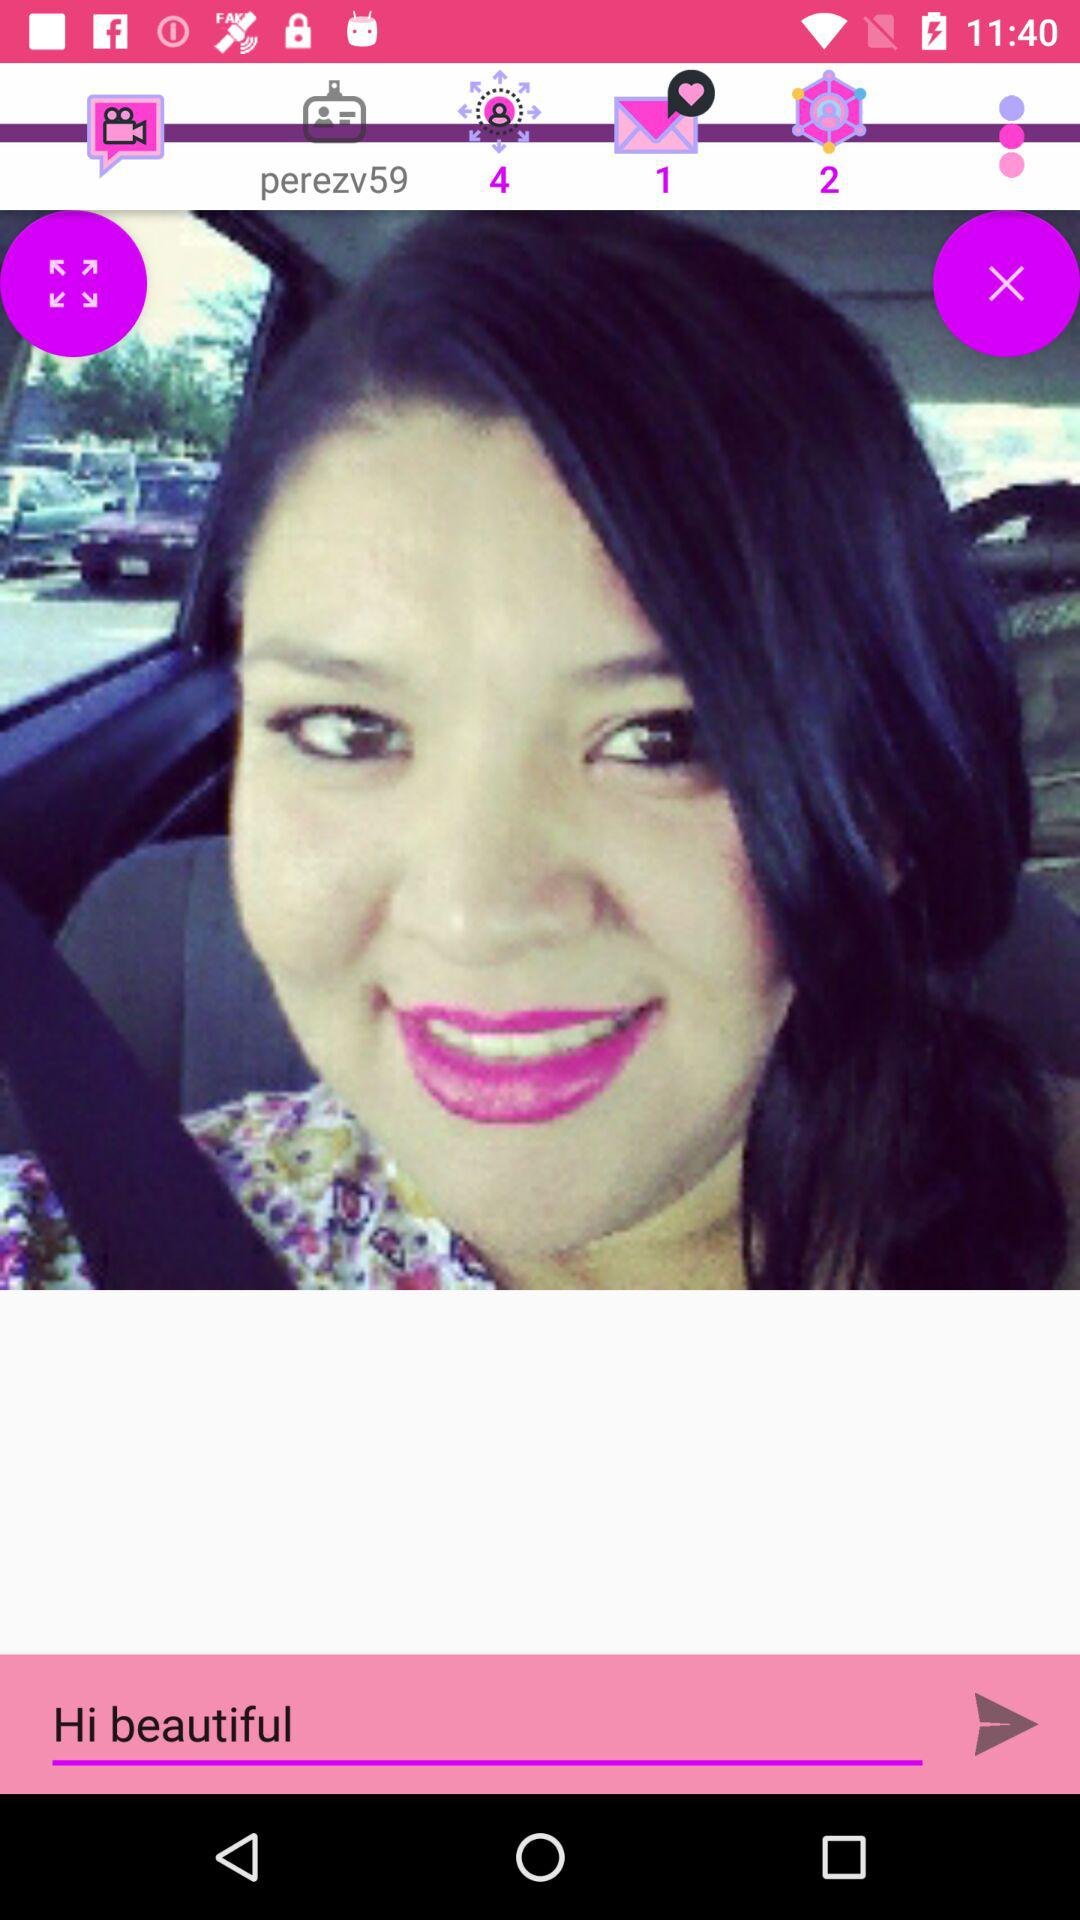What is the username? The username is "perezv59". 